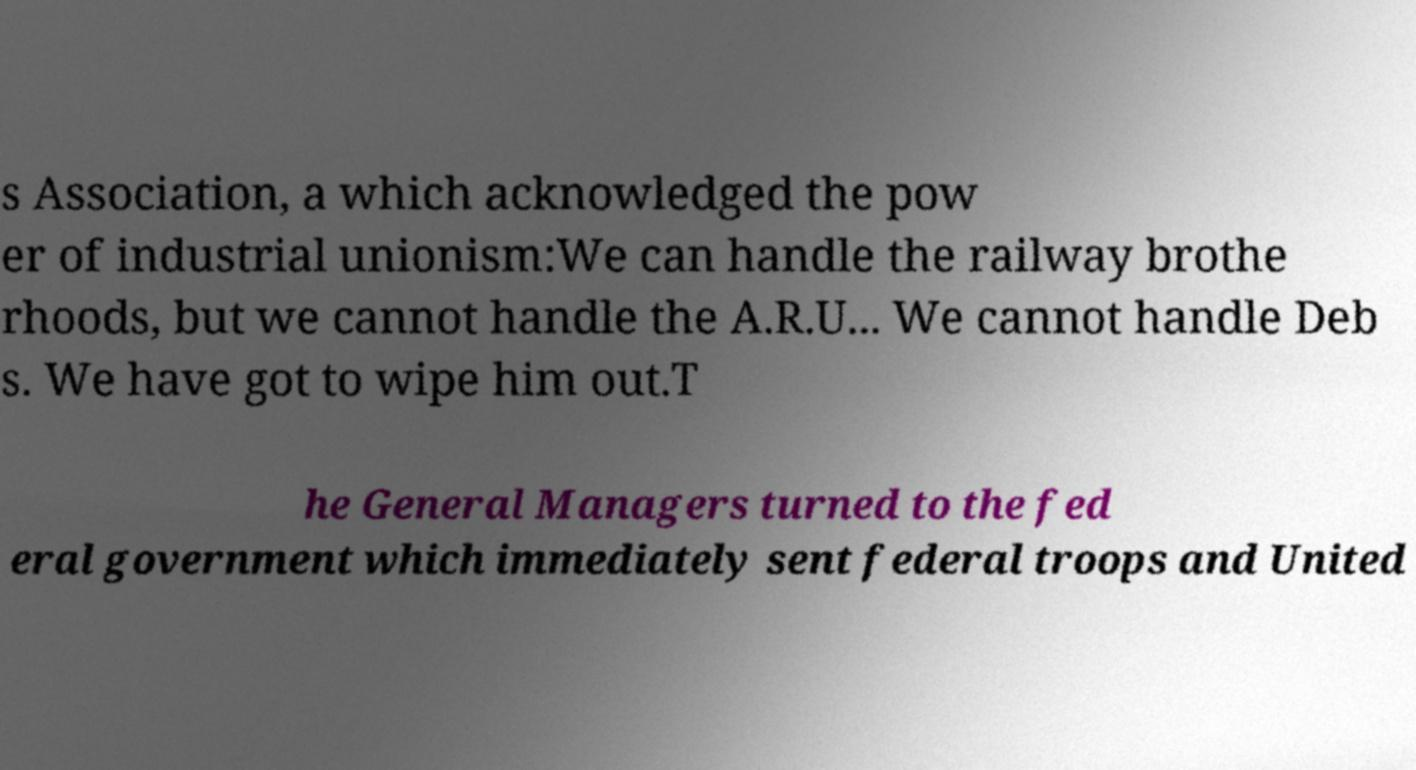Could you extract and type out the text from this image? s Association, a which acknowledged the pow er of industrial unionism:We can handle the railway brothe rhoods, but we cannot handle the A.R.U... We cannot handle Deb s. We have got to wipe him out.T he General Managers turned to the fed eral government which immediately sent federal troops and United 